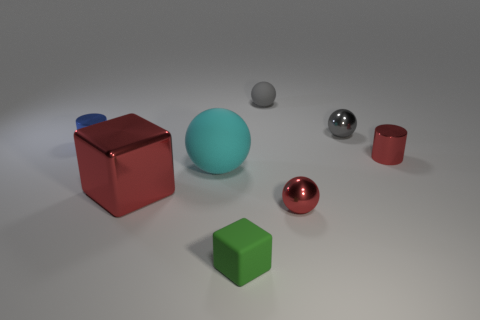Subtract all red shiny balls. How many balls are left? 3 Subtract all brown cylinders. How many gray balls are left? 2 Subtract 1 spheres. How many spheres are left? 3 Subtract all cyan balls. How many balls are left? 3 Add 2 small green matte objects. How many objects exist? 10 Subtract all cubes. How many objects are left? 6 Subtract all brown balls. Subtract all green cylinders. How many balls are left? 4 Add 3 small red metal cylinders. How many small red metal cylinders exist? 4 Subtract 1 red cylinders. How many objects are left? 7 Subtract all big cyan matte balls. Subtract all large red shiny cubes. How many objects are left? 6 